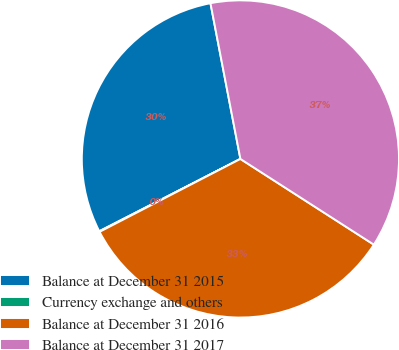<chart> <loc_0><loc_0><loc_500><loc_500><pie_chart><fcel>Balance at December 31 2015<fcel>Currency exchange and others<fcel>Balance at December 31 2016<fcel>Balance at December 31 2017<nl><fcel>29.51%<fcel>0.07%<fcel>33.31%<fcel>37.11%<nl></chart> 